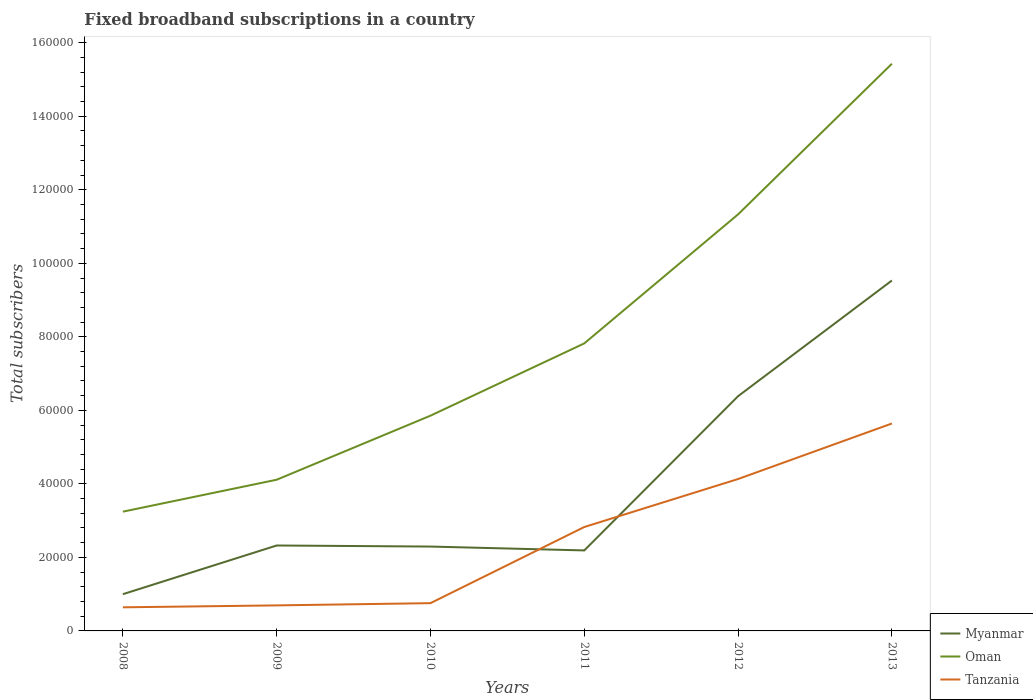How many different coloured lines are there?
Provide a short and direct response. 3. Does the line corresponding to Myanmar intersect with the line corresponding to Oman?
Your answer should be very brief. No. Is the number of lines equal to the number of legend labels?
Offer a terse response. Yes. Across all years, what is the maximum number of broadband subscriptions in Tanzania?
Offer a very short reply. 6422. What is the total number of broadband subscriptions in Tanzania in the graph?
Offer a terse response. -4.89e+04. What is the difference between the highest and the second highest number of broadband subscriptions in Myanmar?
Offer a very short reply. 8.53e+04. How many lines are there?
Make the answer very short. 3. Where does the legend appear in the graph?
Offer a terse response. Bottom right. How many legend labels are there?
Provide a short and direct response. 3. What is the title of the graph?
Provide a short and direct response. Fixed broadband subscriptions in a country. Does "Lithuania" appear as one of the legend labels in the graph?
Make the answer very short. No. What is the label or title of the X-axis?
Your answer should be compact. Years. What is the label or title of the Y-axis?
Make the answer very short. Total subscribers. What is the Total subscribers of Myanmar in 2008?
Ensure brevity in your answer.  9995. What is the Total subscribers of Oman in 2008?
Make the answer very short. 3.24e+04. What is the Total subscribers of Tanzania in 2008?
Your answer should be compact. 6422. What is the Total subscribers of Myanmar in 2009?
Your answer should be compact. 2.32e+04. What is the Total subscribers of Oman in 2009?
Ensure brevity in your answer.  4.11e+04. What is the Total subscribers of Tanzania in 2009?
Your answer should be compact. 6947. What is the Total subscribers of Myanmar in 2010?
Provide a succinct answer. 2.30e+04. What is the Total subscribers in Oman in 2010?
Keep it short and to the point. 5.86e+04. What is the Total subscribers of Tanzania in 2010?
Keep it short and to the point. 7554. What is the Total subscribers of Myanmar in 2011?
Your answer should be compact. 2.19e+04. What is the Total subscribers of Oman in 2011?
Give a very brief answer. 7.82e+04. What is the Total subscribers in Tanzania in 2011?
Your response must be concise. 2.83e+04. What is the Total subscribers of Myanmar in 2012?
Give a very brief answer. 6.39e+04. What is the Total subscribers of Oman in 2012?
Your answer should be very brief. 1.13e+05. What is the Total subscribers in Tanzania in 2012?
Keep it short and to the point. 4.13e+04. What is the Total subscribers of Myanmar in 2013?
Your response must be concise. 9.53e+04. What is the Total subscribers in Oman in 2013?
Ensure brevity in your answer.  1.54e+05. What is the Total subscribers in Tanzania in 2013?
Provide a succinct answer. 5.64e+04. Across all years, what is the maximum Total subscribers of Myanmar?
Make the answer very short. 9.53e+04. Across all years, what is the maximum Total subscribers of Oman?
Your response must be concise. 1.54e+05. Across all years, what is the maximum Total subscribers of Tanzania?
Provide a short and direct response. 5.64e+04. Across all years, what is the minimum Total subscribers in Myanmar?
Provide a short and direct response. 9995. Across all years, what is the minimum Total subscribers in Oman?
Ensure brevity in your answer.  3.24e+04. Across all years, what is the minimum Total subscribers of Tanzania?
Make the answer very short. 6422. What is the total Total subscribers in Myanmar in the graph?
Offer a terse response. 2.37e+05. What is the total Total subscribers of Oman in the graph?
Offer a very short reply. 4.78e+05. What is the total Total subscribers of Tanzania in the graph?
Offer a very short reply. 1.47e+05. What is the difference between the Total subscribers in Myanmar in 2008 and that in 2009?
Your answer should be compact. -1.32e+04. What is the difference between the Total subscribers of Oman in 2008 and that in 2009?
Give a very brief answer. -8684. What is the difference between the Total subscribers in Tanzania in 2008 and that in 2009?
Ensure brevity in your answer.  -525. What is the difference between the Total subscribers in Myanmar in 2008 and that in 2010?
Keep it short and to the point. -1.30e+04. What is the difference between the Total subscribers of Oman in 2008 and that in 2010?
Make the answer very short. -2.61e+04. What is the difference between the Total subscribers in Tanzania in 2008 and that in 2010?
Your answer should be compact. -1132. What is the difference between the Total subscribers of Myanmar in 2008 and that in 2011?
Provide a succinct answer. -1.19e+04. What is the difference between the Total subscribers in Oman in 2008 and that in 2011?
Offer a very short reply. -4.58e+04. What is the difference between the Total subscribers of Tanzania in 2008 and that in 2011?
Your answer should be compact. -2.18e+04. What is the difference between the Total subscribers of Myanmar in 2008 and that in 2012?
Keep it short and to the point. -5.39e+04. What is the difference between the Total subscribers of Oman in 2008 and that in 2012?
Provide a succinct answer. -8.09e+04. What is the difference between the Total subscribers of Tanzania in 2008 and that in 2012?
Keep it short and to the point. -3.49e+04. What is the difference between the Total subscribers of Myanmar in 2008 and that in 2013?
Offer a very short reply. -8.53e+04. What is the difference between the Total subscribers of Oman in 2008 and that in 2013?
Give a very brief answer. -1.22e+05. What is the difference between the Total subscribers in Tanzania in 2008 and that in 2013?
Your answer should be compact. -5.00e+04. What is the difference between the Total subscribers in Myanmar in 2009 and that in 2010?
Keep it short and to the point. 290. What is the difference between the Total subscribers of Oman in 2009 and that in 2010?
Offer a very short reply. -1.74e+04. What is the difference between the Total subscribers of Tanzania in 2009 and that in 2010?
Keep it short and to the point. -607. What is the difference between the Total subscribers of Myanmar in 2009 and that in 2011?
Your answer should be very brief. 1342. What is the difference between the Total subscribers in Oman in 2009 and that in 2011?
Offer a very short reply. -3.71e+04. What is the difference between the Total subscribers of Tanzania in 2009 and that in 2011?
Offer a terse response. -2.13e+04. What is the difference between the Total subscribers in Myanmar in 2009 and that in 2012?
Make the answer very short. -4.06e+04. What is the difference between the Total subscribers in Oman in 2009 and that in 2012?
Provide a succinct answer. -7.22e+04. What is the difference between the Total subscribers in Tanzania in 2009 and that in 2012?
Your response must be concise. -3.44e+04. What is the difference between the Total subscribers of Myanmar in 2009 and that in 2013?
Offer a very short reply. -7.21e+04. What is the difference between the Total subscribers in Oman in 2009 and that in 2013?
Your answer should be very brief. -1.13e+05. What is the difference between the Total subscribers of Tanzania in 2009 and that in 2013?
Your response must be concise. -4.95e+04. What is the difference between the Total subscribers of Myanmar in 2010 and that in 2011?
Your response must be concise. 1052. What is the difference between the Total subscribers in Oman in 2010 and that in 2011?
Your answer should be very brief. -1.97e+04. What is the difference between the Total subscribers of Tanzania in 2010 and that in 2011?
Offer a very short reply. -2.07e+04. What is the difference between the Total subscribers in Myanmar in 2010 and that in 2012?
Provide a short and direct response. -4.09e+04. What is the difference between the Total subscribers of Oman in 2010 and that in 2012?
Provide a succinct answer. -5.48e+04. What is the difference between the Total subscribers in Tanzania in 2010 and that in 2012?
Provide a short and direct response. -3.38e+04. What is the difference between the Total subscribers in Myanmar in 2010 and that in 2013?
Offer a very short reply. -7.24e+04. What is the difference between the Total subscribers in Oman in 2010 and that in 2013?
Offer a very short reply. -9.57e+04. What is the difference between the Total subscribers of Tanzania in 2010 and that in 2013?
Your answer should be very brief. -4.89e+04. What is the difference between the Total subscribers in Myanmar in 2011 and that in 2012?
Your answer should be very brief. -4.20e+04. What is the difference between the Total subscribers of Oman in 2011 and that in 2012?
Give a very brief answer. -3.51e+04. What is the difference between the Total subscribers of Tanzania in 2011 and that in 2012?
Offer a very short reply. -1.31e+04. What is the difference between the Total subscribers in Myanmar in 2011 and that in 2013?
Your answer should be very brief. -7.34e+04. What is the difference between the Total subscribers of Oman in 2011 and that in 2013?
Ensure brevity in your answer.  -7.61e+04. What is the difference between the Total subscribers of Tanzania in 2011 and that in 2013?
Give a very brief answer. -2.82e+04. What is the difference between the Total subscribers in Myanmar in 2012 and that in 2013?
Provide a short and direct response. -3.15e+04. What is the difference between the Total subscribers in Oman in 2012 and that in 2013?
Make the answer very short. -4.10e+04. What is the difference between the Total subscribers in Tanzania in 2012 and that in 2013?
Give a very brief answer. -1.51e+04. What is the difference between the Total subscribers in Myanmar in 2008 and the Total subscribers in Oman in 2009?
Provide a succinct answer. -3.11e+04. What is the difference between the Total subscribers of Myanmar in 2008 and the Total subscribers of Tanzania in 2009?
Offer a terse response. 3048. What is the difference between the Total subscribers in Oman in 2008 and the Total subscribers in Tanzania in 2009?
Offer a very short reply. 2.55e+04. What is the difference between the Total subscribers in Myanmar in 2008 and the Total subscribers in Oman in 2010?
Give a very brief answer. -4.86e+04. What is the difference between the Total subscribers in Myanmar in 2008 and the Total subscribers in Tanzania in 2010?
Your response must be concise. 2441. What is the difference between the Total subscribers of Oman in 2008 and the Total subscribers of Tanzania in 2010?
Offer a terse response. 2.49e+04. What is the difference between the Total subscribers in Myanmar in 2008 and the Total subscribers in Oman in 2011?
Keep it short and to the point. -6.82e+04. What is the difference between the Total subscribers in Myanmar in 2008 and the Total subscribers in Tanzania in 2011?
Offer a very short reply. -1.83e+04. What is the difference between the Total subscribers in Oman in 2008 and the Total subscribers in Tanzania in 2011?
Make the answer very short. 4179. What is the difference between the Total subscribers in Myanmar in 2008 and the Total subscribers in Oman in 2012?
Your answer should be compact. -1.03e+05. What is the difference between the Total subscribers in Myanmar in 2008 and the Total subscribers in Tanzania in 2012?
Ensure brevity in your answer.  -3.13e+04. What is the difference between the Total subscribers of Oman in 2008 and the Total subscribers of Tanzania in 2012?
Offer a very short reply. -8878. What is the difference between the Total subscribers in Myanmar in 2008 and the Total subscribers in Oman in 2013?
Keep it short and to the point. -1.44e+05. What is the difference between the Total subscribers in Myanmar in 2008 and the Total subscribers in Tanzania in 2013?
Provide a short and direct response. -4.64e+04. What is the difference between the Total subscribers in Oman in 2008 and the Total subscribers in Tanzania in 2013?
Your response must be concise. -2.40e+04. What is the difference between the Total subscribers in Myanmar in 2009 and the Total subscribers in Oman in 2010?
Provide a succinct answer. -3.53e+04. What is the difference between the Total subscribers of Myanmar in 2009 and the Total subscribers of Tanzania in 2010?
Provide a short and direct response. 1.57e+04. What is the difference between the Total subscribers of Oman in 2009 and the Total subscribers of Tanzania in 2010?
Your answer should be very brief. 3.36e+04. What is the difference between the Total subscribers of Myanmar in 2009 and the Total subscribers of Oman in 2011?
Provide a short and direct response. -5.50e+04. What is the difference between the Total subscribers in Myanmar in 2009 and the Total subscribers in Tanzania in 2011?
Your answer should be very brief. -5028. What is the difference between the Total subscribers in Oman in 2009 and the Total subscribers in Tanzania in 2011?
Your answer should be very brief. 1.29e+04. What is the difference between the Total subscribers of Myanmar in 2009 and the Total subscribers of Oman in 2012?
Offer a terse response. -9.01e+04. What is the difference between the Total subscribers of Myanmar in 2009 and the Total subscribers of Tanzania in 2012?
Give a very brief answer. -1.81e+04. What is the difference between the Total subscribers in Oman in 2009 and the Total subscribers in Tanzania in 2012?
Offer a terse response. -194. What is the difference between the Total subscribers in Myanmar in 2009 and the Total subscribers in Oman in 2013?
Keep it short and to the point. -1.31e+05. What is the difference between the Total subscribers of Myanmar in 2009 and the Total subscribers of Tanzania in 2013?
Offer a very short reply. -3.32e+04. What is the difference between the Total subscribers of Oman in 2009 and the Total subscribers of Tanzania in 2013?
Your answer should be very brief. -1.53e+04. What is the difference between the Total subscribers in Myanmar in 2010 and the Total subscribers in Oman in 2011?
Your response must be concise. -5.53e+04. What is the difference between the Total subscribers of Myanmar in 2010 and the Total subscribers of Tanzania in 2011?
Offer a terse response. -5318. What is the difference between the Total subscribers in Oman in 2010 and the Total subscribers in Tanzania in 2011?
Your answer should be very brief. 3.03e+04. What is the difference between the Total subscribers in Myanmar in 2010 and the Total subscribers in Oman in 2012?
Provide a short and direct response. -9.04e+04. What is the difference between the Total subscribers in Myanmar in 2010 and the Total subscribers in Tanzania in 2012?
Give a very brief answer. -1.84e+04. What is the difference between the Total subscribers of Oman in 2010 and the Total subscribers of Tanzania in 2012?
Provide a succinct answer. 1.72e+04. What is the difference between the Total subscribers in Myanmar in 2010 and the Total subscribers in Oman in 2013?
Keep it short and to the point. -1.31e+05. What is the difference between the Total subscribers of Myanmar in 2010 and the Total subscribers of Tanzania in 2013?
Your answer should be compact. -3.35e+04. What is the difference between the Total subscribers of Oman in 2010 and the Total subscribers of Tanzania in 2013?
Provide a short and direct response. 2131. What is the difference between the Total subscribers in Myanmar in 2011 and the Total subscribers in Oman in 2012?
Offer a very short reply. -9.14e+04. What is the difference between the Total subscribers in Myanmar in 2011 and the Total subscribers in Tanzania in 2012?
Provide a short and direct response. -1.94e+04. What is the difference between the Total subscribers in Oman in 2011 and the Total subscribers in Tanzania in 2012?
Provide a short and direct response. 3.69e+04. What is the difference between the Total subscribers of Myanmar in 2011 and the Total subscribers of Oman in 2013?
Make the answer very short. -1.32e+05. What is the difference between the Total subscribers of Myanmar in 2011 and the Total subscribers of Tanzania in 2013?
Provide a short and direct response. -3.45e+04. What is the difference between the Total subscribers of Oman in 2011 and the Total subscribers of Tanzania in 2013?
Your answer should be compact. 2.18e+04. What is the difference between the Total subscribers of Myanmar in 2012 and the Total subscribers of Oman in 2013?
Make the answer very short. -9.04e+04. What is the difference between the Total subscribers of Myanmar in 2012 and the Total subscribers of Tanzania in 2013?
Give a very brief answer. 7434. What is the difference between the Total subscribers in Oman in 2012 and the Total subscribers in Tanzania in 2013?
Your answer should be compact. 5.69e+04. What is the average Total subscribers in Myanmar per year?
Ensure brevity in your answer.  3.95e+04. What is the average Total subscribers of Oman per year?
Give a very brief answer. 7.97e+04. What is the average Total subscribers of Tanzania per year?
Provide a succinct answer. 2.45e+04. In the year 2008, what is the difference between the Total subscribers in Myanmar and Total subscribers in Oman?
Your response must be concise. -2.25e+04. In the year 2008, what is the difference between the Total subscribers in Myanmar and Total subscribers in Tanzania?
Offer a terse response. 3573. In the year 2008, what is the difference between the Total subscribers of Oman and Total subscribers of Tanzania?
Provide a short and direct response. 2.60e+04. In the year 2009, what is the difference between the Total subscribers of Myanmar and Total subscribers of Oman?
Your response must be concise. -1.79e+04. In the year 2009, what is the difference between the Total subscribers in Myanmar and Total subscribers in Tanzania?
Give a very brief answer. 1.63e+04. In the year 2009, what is the difference between the Total subscribers in Oman and Total subscribers in Tanzania?
Make the answer very short. 3.42e+04. In the year 2010, what is the difference between the Total subscribers in Myanmar and Total subscribers in Oman?
Provide a short and direct response. -3.56e+04. In the year 2010, what is the difference between the Total subscribers in Myanmar and Total subscribers in Tanzania?
Ensure brevity in your answer.  1.54e+04. In the year 2010, what is the difference between the Total subscribers of Oman and Total subscribers of Tanzania?
Your response must be concise. 5.10e+04. In the year 2011, what is the difference between the Total subscribers in Myanmar and Total subscribers in Oman?
Provide a succinct answer. -5.63e+04. In the year 2011, what is the difference between the Total subscribers in Myanmar and Total subscribers in Tanzania?
Give a very brief answer. -6370. In the year 2011, what is the difference between the Total subscribers of Oman and Total subscribers of Tanzania?
Offer a very short reply. 4.99e+04. In the year 2012, what is the difference between the Total subscribers in Myanmar and Total subscribers in Oman?
Provide a short and direct response. -4.95e+04. In the year 2012, what is the difference between the Total subscribers of Myanmar and Total subscribers of Tanzania?
Ensure brevity in your answer.  2.25e+04. In the year 2012, what is the difference between the Total subscribers of Oman and Total subscribers of Tanzania?
Provide a short and direct response. 7.20e+04. In the year 2013, what is the difference between the Total subscribers of Myanmar and Total subscribers of Oman?
Provide a short and direct response. -5.90e+04. In the year 2013, what is the difference between the Total subscribers of Myanmar and Total subscribers of Tanzania?
Ensure brevity in your answer.  3.89e+04. In the year 2013, what is the difference between the Total subscribers of Oman and Total subscribers of Tanzania?
Offer a terse response. 9.79e+04. What is the ratio of the Total subscribers in Myanmar in 2008 to that in 2009?
Give a very brief answer. 0.43. What is the ratio of the Total subscribers of Oman in 2008 to that in 2009?
Ensure brevity in your answer.  0.79. What is the ratio of the Total subscribers of Tanzania in 2008 to that in 2009?
Your answer should be compact. 0.92. What is the ratio of the Total subscribers of Myanmar in 2008 to that in 2010?
Give a very brief answer. 0.44. What is the ratio of the Total subscribers in Oman in 2008 to that in 2010?
Your response must be concise. 0.55. What is the ratio of the Total subscribers of Tanzania in 2008 to that in 2010?
Make the answer very short. 0.85. What is the ratio of the Total subscribers in Myanmar in 2008 to that in 2011?
Give a very brief answer. 0.46. What is the ratio of the Total subscribers in Oman in 2008 to that in 2011?
Offer a terse response. 0.41. What is the ratio of the Total subscribers in Tanzania in 2008 to that in 2011?
Ensure brevity in your answer.  0.23. What is the ratio of the Total subscribers in Myanmar in 2008 to that in 2012?
Offer a terse response. 0.16. What is the ratio of the Total subscribers of Oman in 2008 to that in 2012?
Your answer should be very brief. 0.29. What is the ratio of the Total subscribers in Tanzania in 2008 to that in 2012?
Keep it short and to the point. 0.16. What is the ratio of the Total subscribers of Myanmar in 2008 to that in 2013?
Your answer should be very brief. 0.1. What is the ratio of the Total subscribers in Oman in 2008 to that in 2013?
Offer a very short reply. 0.21. What is the ratio of the Total subscribers in Tanzania in 2008 to that in 2013?
Your answer should be very brief. 0.11. What is the ratio of the Total subscribers of Myanmar in 2009 to that in 2010?
Give a very brief answer. 1.01. What is the ratio of the Total subscribers in Oman in 2009 to that in 2010?
Provide a succinct answer. 0.7. What is the ratio of the Total subscribers in Tanzania in 2009 to that in 2010?
Keep it short and to the point. 0.92. What is the ratio of the Total subscribers in Myanmar in 2009 to that in 2011?
Make the answer very short. 1.06. What is the ratio of the Total subscribers of Oman in 2009 to that in 2011?
Make the answer very short. 0.53. What is the ratio of the Total subscribers of Tanzania in 2009 to that in 2011?
Make the answer very short. 0.25. What is the ratio of the Total subscribers in Myanmar in 2009 to that in 2012?
Your answer should be very brief. 0.36. What is the ratio of the Total subscribers of Oman in 2009 to that in 2012?
Give a very brief answer. 0.36. What is the ratio of the Total subscribers in Tanzania in 2009 to that in 2012?
Ensure brevity in your answer.  0.17. What is the ratio of the Total subscribers in Myanmar in 2009 to that in 2013?
Your answer should be compact. 0.24. What is the ratio of the Total subscribers in Oman in 2009 to that in 2013?
Keep it short and to the point. 0.27. What is the ratio of the Total subscribers of Tanzania in 2009 to that in 2013?
Provide a succinct answer. 0.12. What is the ratio of the Total subscribers in Myanmar in 2010 to that in 2011?
Provide a succinct answer. 1.05. What is the ratio of the Total subscribers in Oman in 2010 to that in 2011?
Provide a succinct answer. 0.75. What is the ratio of the Total subscribers of Tanzania in 2010 to that in 2011?
Offer a terse response. 0.27. What is the ratio of the Total subscribers of Myanmar in 2010 to that in 2012?
Offer a terse response. 0.36. What is the ratio of the Total subscribers of Oman in 2010 to that in 2012?
Offer a very short reply. 0.52. What is the ratio of the Total subscribers in Tanzania in 2010 to that in 2012?
Offer a very short reply. 0.18. What is the ratio of the Total subscribers of Myanmar in 2010 to that in 2013?
Offer a terse response. 0.24. What is the ratio of the Total subscribers in Oman in 2010 to that in 2013?
Offer a very short reply. 0.38. What is the ratio of the Total subscribers in Tanzania in 2010 to that in 2013?
Provide a succinct answer. 0.13. What is the ratio of the Total subscribers of Myanmar in 2011 to that in 2012?
Provide a succinct answer. 0.34. What is the ratio of the Total subscribers of Oman in 2011 to that in 2012?
Make the answer very short. 0.69. What is the ratio of the Total subscribers of Tanzania in 2011 to that in 2012?
Keep it short and to the point. 0.68. What is the ratio of the Total subscribers in Myanmar in 2011 to that in 2013?
Provide a succinct answer. 0.23. What is the ratio of the Total subscribers of Oman in 2011 to that in 2013?
Make the answer very short. 0.51. What is the ratio of the Total subscribers in Tanzania in 2011 to that in 2013?
Provide a succinct answer. 0.5. What is the ratio of the Total subscribers in Myanmar in 2012 to that in 2013?
Provide a succinct answer. 0.67. What is the ratio of the Total subscribers in Oman in 2012 to that in 2013?
Provide a succinct answer. 0.73. What is the ratio of the Total subscribers in Tanzania in 2012 to that in 2013?
Give a very brief answer. 0.73. What is the difference between the highest and the second highest Total subscribers of Myanmar?
Your answer should be very brief. 3.15e+04. What is the difference between the highest and the second highest Total subscribers in Oman?
Your answer should be very brief. 4.10e+04. What is the difference between the highest and the second highest Total subscribers of Tanzania?
Keep it short and to the point. 1.51e+04. What is the difference between the highest and the lowest Total subscribers of Myanmar?
Your response must be concise. 8.53e+04. What is the difference between the highest and the lowest Total subscribers in Oman?
Give a very brief answer. 1.22e+05. What is the difference between the highest and the lowest Total subscribers in Tanzania?
Make the answer very short. 5.00e+04. 